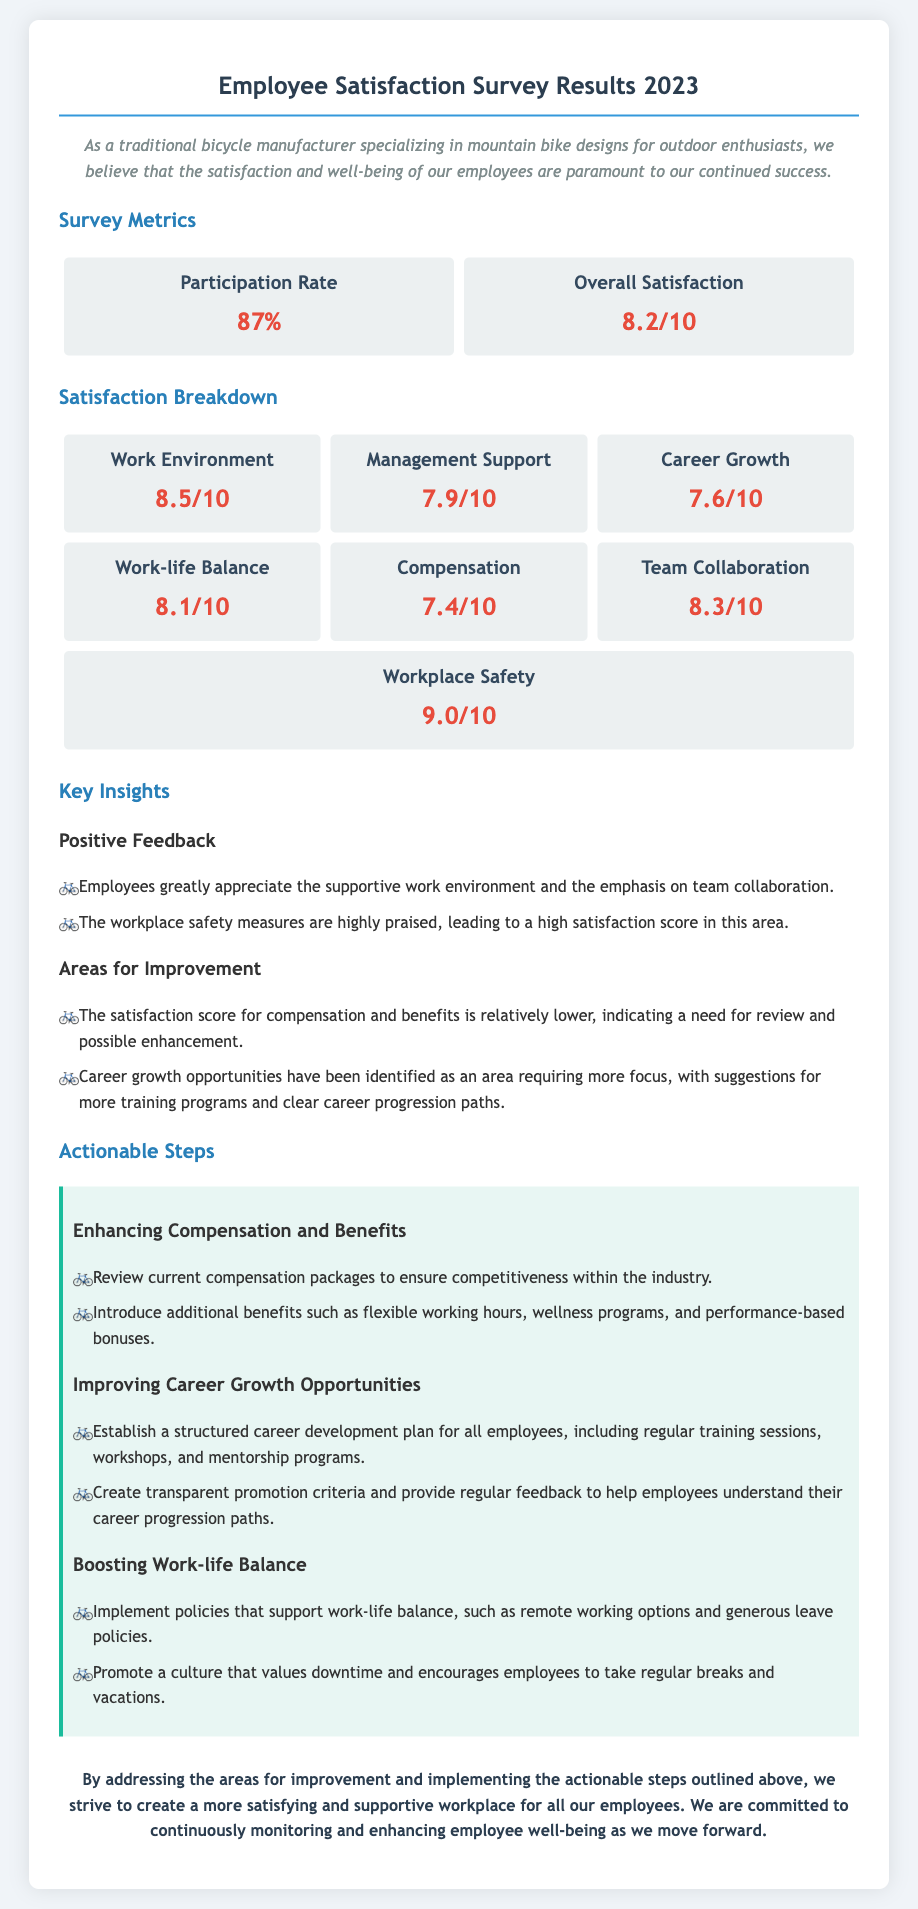What was the participation rate in the survey? The participation rate is specifically stated in the survey metrics section of the document.
Answer: 87% What is the overall satisfaction score from the survey? The overall satisfaction score is displayed clearly in the survey metrics section.
Answer: 8.2/10 How did employees rate the work environment? The survey provides a satisfaction score for the work environment in the satisfaction breakdown section.
Answer: 8.5/10 What area received the highest satisfaction score? The document lists satisfaction scores, and the highest score can be found in the workplace safety category.
Answer: 9.0/10 What was identified as an area requiring more focus? The document notes specific areas for improvement, which indicates a need for more training programs related to career growth.
Answer: Career growth List one step suggested to enhance compensation and benefits. The actionable steps section outlines several suggestions, including reviewing current compensation packages.
Answer: Review current compensation packages What is one of the suggested steps for improving work-life balance? The actionable steps include various initiatives to improve work-life balance, one of which can be found in the suggestions listed in the document.
Answer: Implement remote working options How is team collaboration rated in the survey? The document includes a satisfaction score for team collaboration in the satisfaction breakdown.
Answer: 8.3/10 What is mentioned as highly praised by employees? The key insights section highlights positive feedback regarding specific workplace aspects appreciated by employees.
Answer: Supportive work environment 